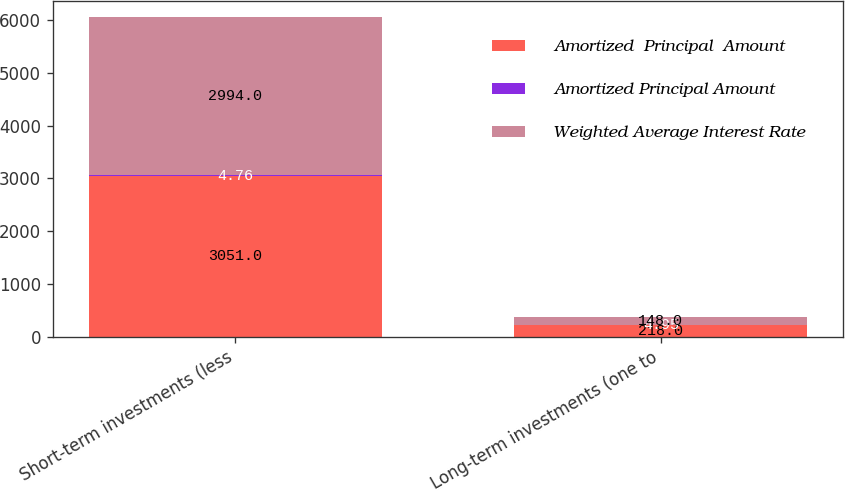Convert chart. <chart><loc_0><loc_0><loc_500><loc_500><stacked_bar_chart><ecel><fcel>Short-term investments (less<fcel>Long-term investments (one to<nl><fcel>Amortized  Principal  Amount<fcel>3051<fcel>218<nl><fcel>Amortized Principal Amount<fcel>4.76<fcel>4.95<nl><fcel>Weighted Average Interest Rate<fcel>2994<fcel>148<nl></chart> 